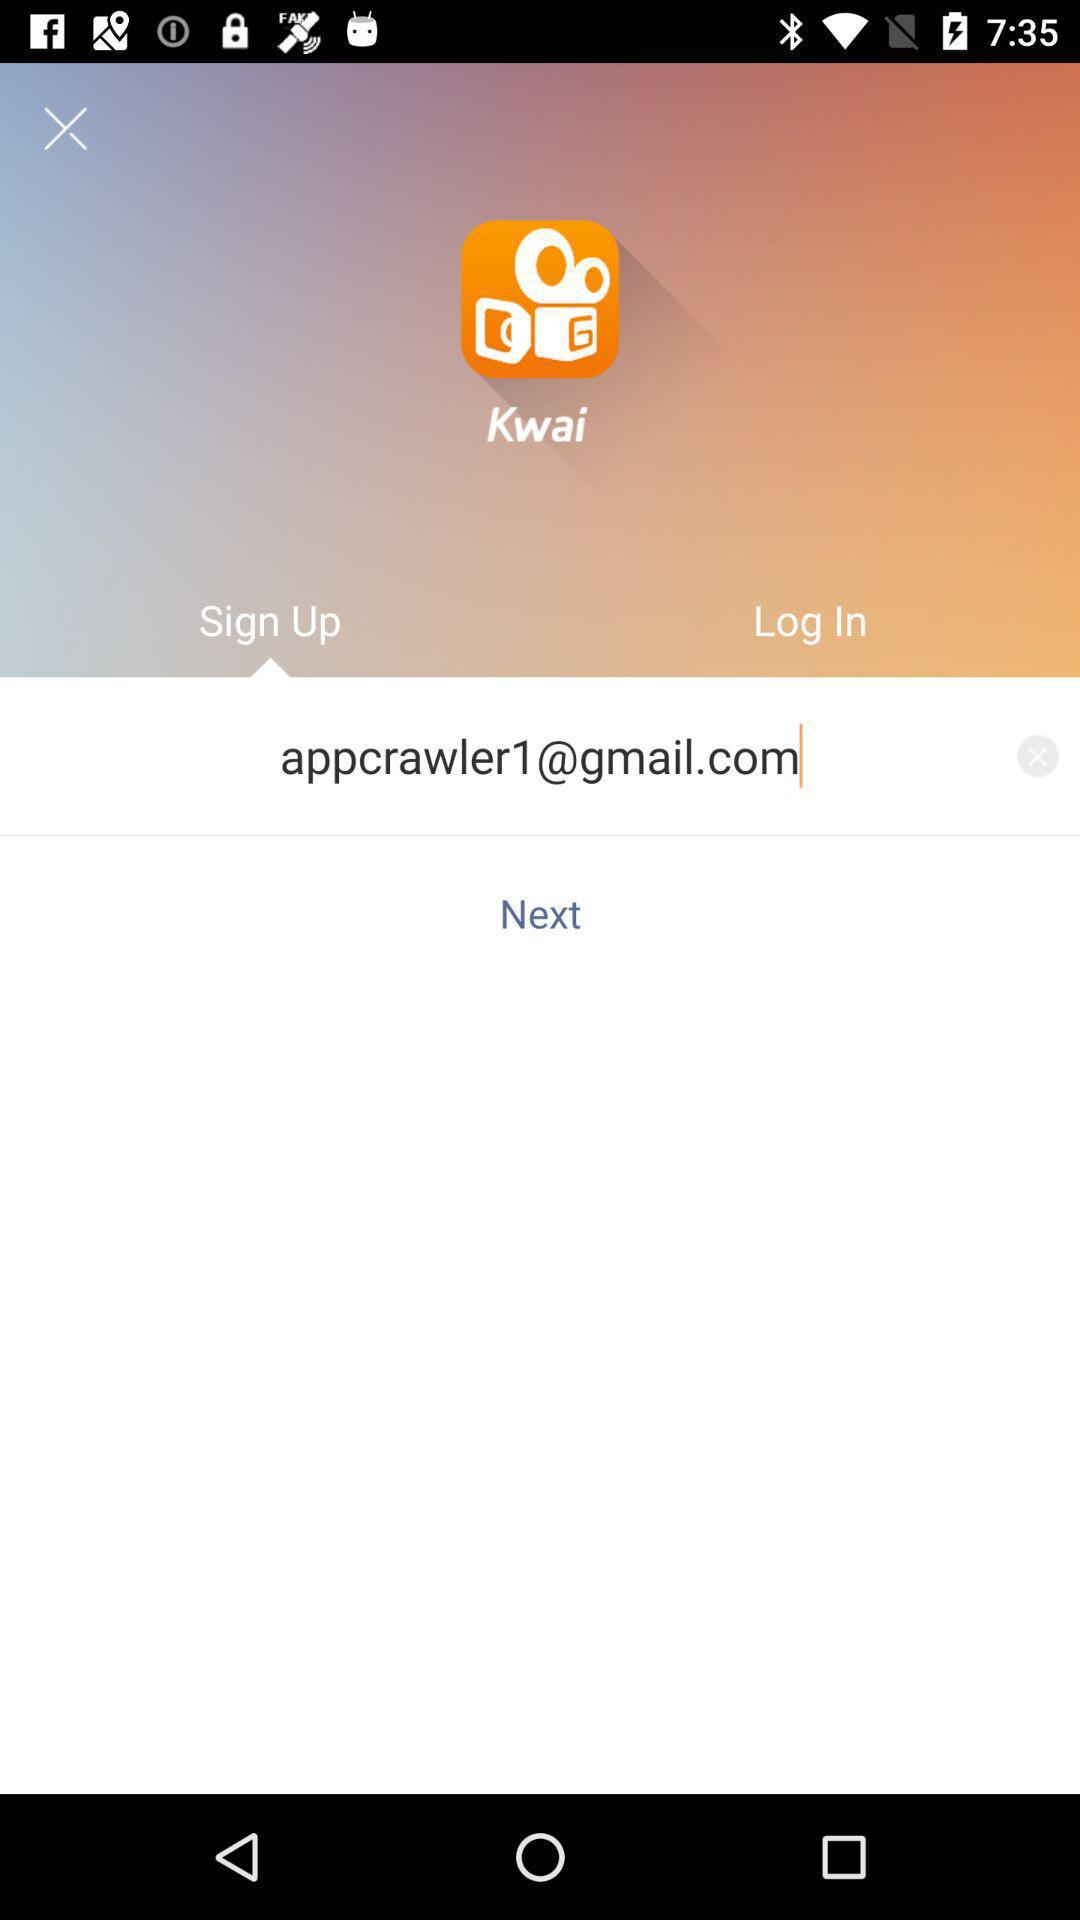What is the email address? The email address is appcrawler1@gmail.com. 